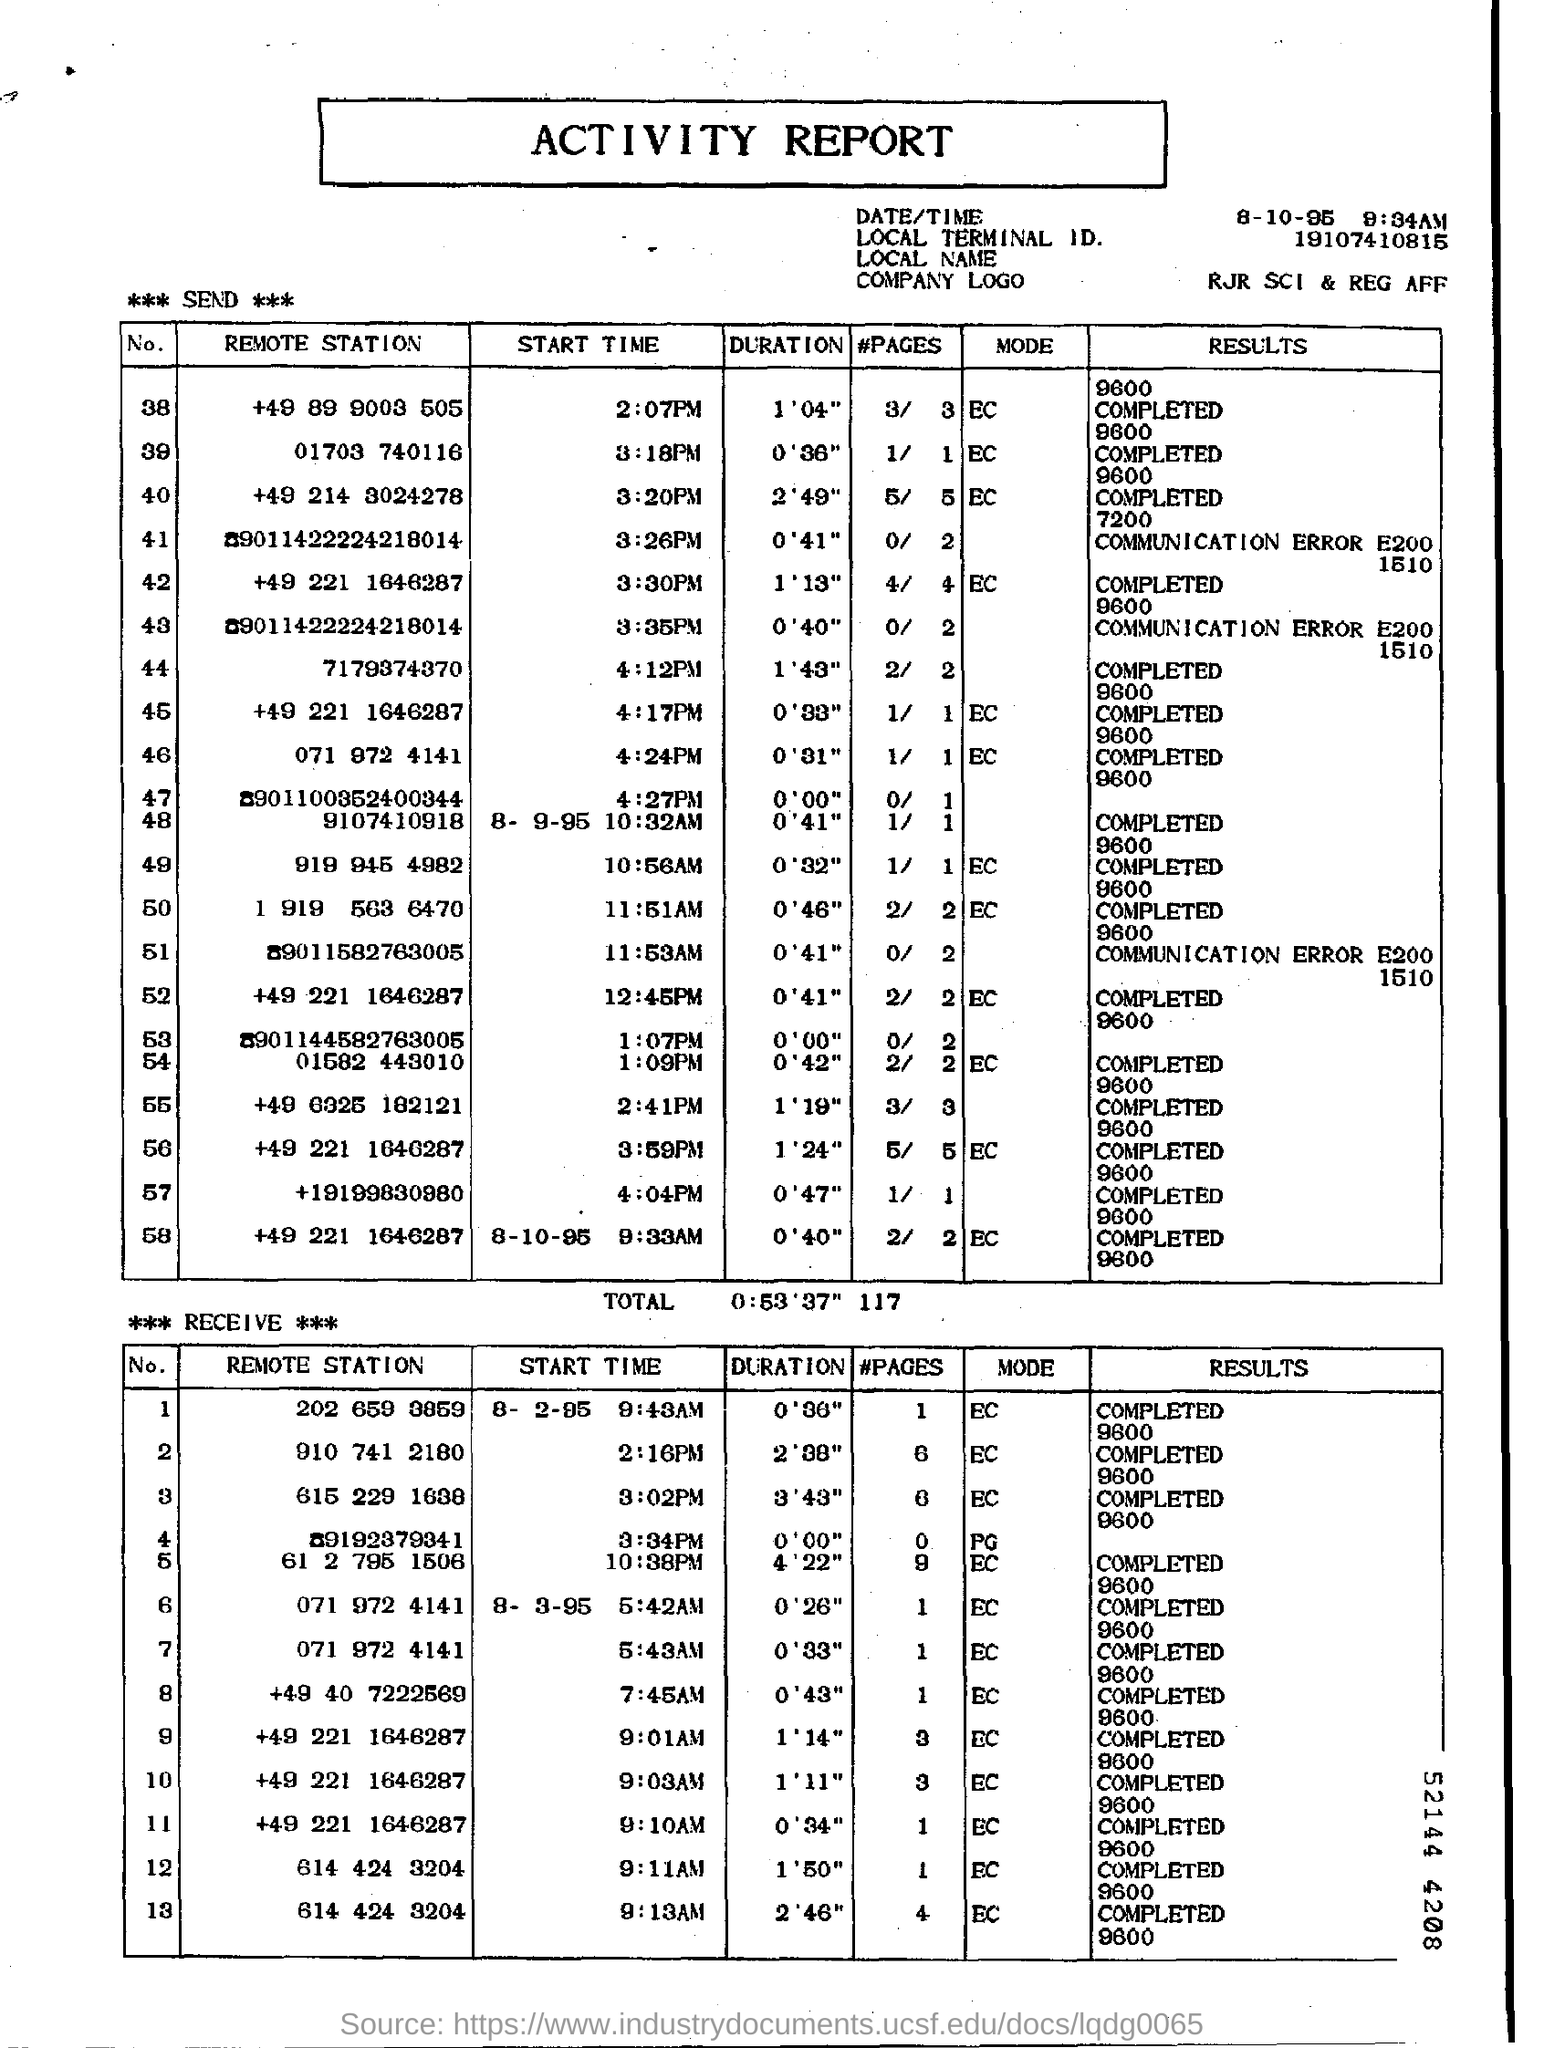Mention a couple of crucial points in this snapshot. This is the Activity Report. RJR SCI & REG AFF is the company logo presented in this report. 